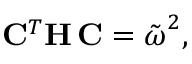Convert formula to latex. <formula><loc_0><loc_0><loc_500><loc_500>{ C } ^ { T } { H } \, { C } = \tilde { \omega } ^ { 2 } ,</formula> 